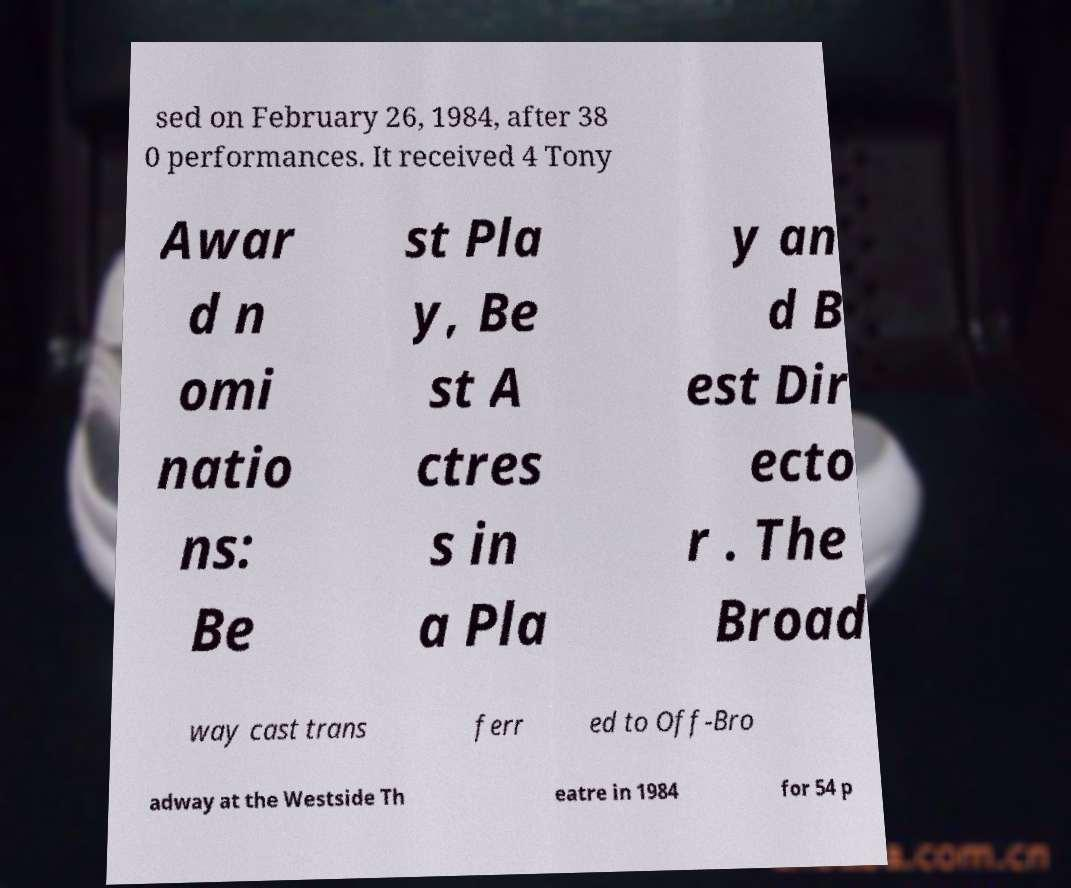There's text embedded in this image that I need extracted. Can you transcribe it verbatim? sed on February 26, 1984, after 38 0 performances. It received 4 Tony Awar d n omi natio ns: Be st Pla y, Be st A ctres s in a Pla y an d B est Dir ecto r . The Broad way cast trans ferr ed to Off-Bro adway at the Westside Th eatre in 1984 for 54 p 